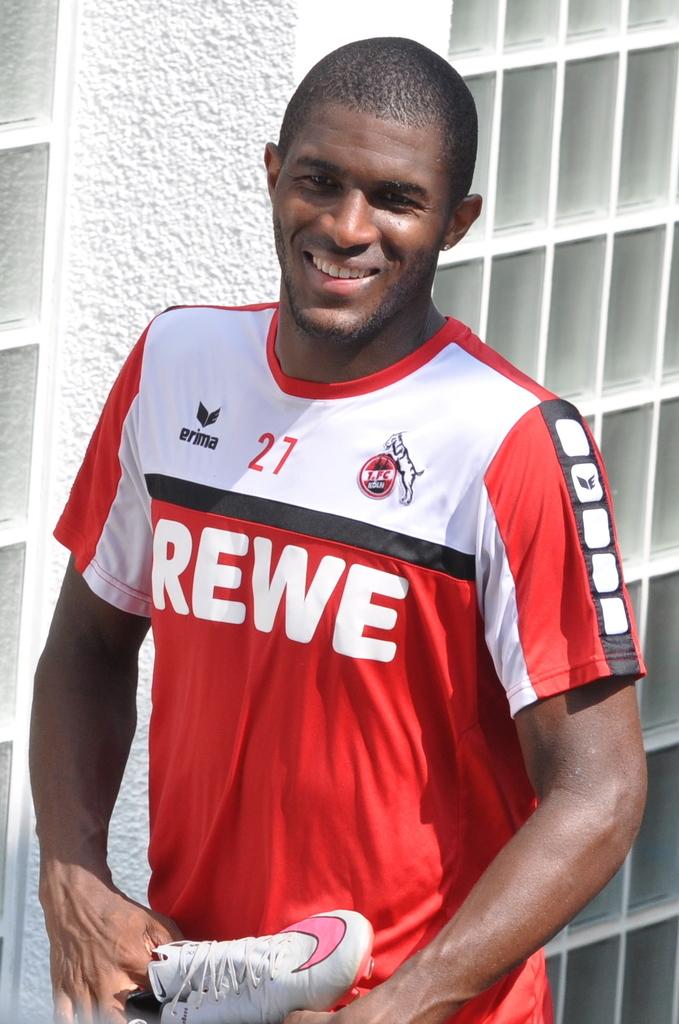What team is on the shirt?
Make the answer very short. Rewe. 